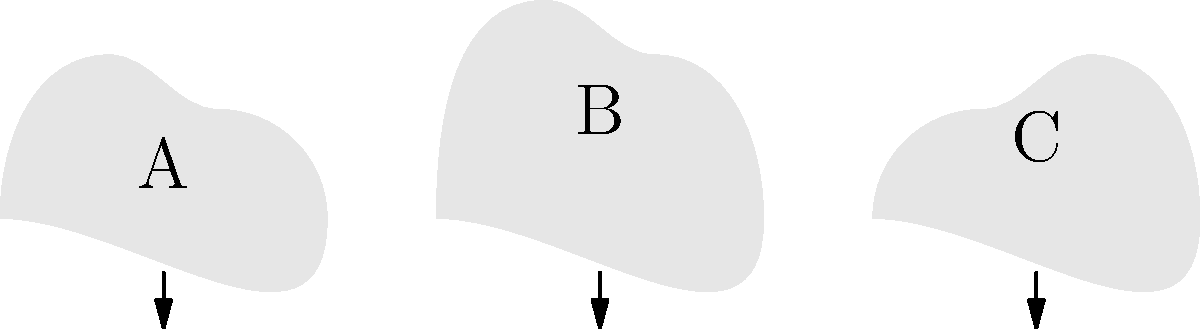Based on your experience with Pacific Island weather patterns, which of the cloud formations (A, B, or C) is most likely to indicate an approaching tropical cyclone in the Palau region? To answer this question, we need to consider the characteristics of cloud formations associated with tropical cyclones in the Pacific Island region, particularly near Palau:

1. Tropical cyclones typically have a distinctive cloud pattern:
   - The center (eye) is often surrounded by a wall of intense thunderstorms.
   - Bands of clouds spiral outward from the center.

2. Analyzing the cloud formations in the image:
   - Cloud A: Low, flat cloud with minimal vertical development.
   - Cloud B: Tall, vertically developed cloud with a distinct anvil shape at the top.
   - Cloud C: Medium-height cloud with some vertical development, but not as pronounced as B.

3. Characteristics of approaching tropical cyclones:
   - They often feature tall, vertically developed cumulonimbus clouds.
   - These clouds can reach heights of up to 50,000 feet or more.
   - The anvil shape at the top is caused by strong winds in the upper atmosphere.

4. Considering Palau's location:
   - Palau is in the western Pacific, an area prone to tropical cyclones.
   - The region experiences monsoon-influenced weather patterns.

5. Conclusion:
   Cloud formation B most closely resembles the characteristics of clouds associated with tropical cyclones:
   - It has significant vertical development.
   - The anvil shape at the top indicates strong upper-level winds.
   - Its size and structure suggest intense convection, typical of cyclonic activity.

Therefore, based on this analysis, cloud formation B is most likely to indicate an approaching tropical cyclone in the Palau region.
Answer: B 